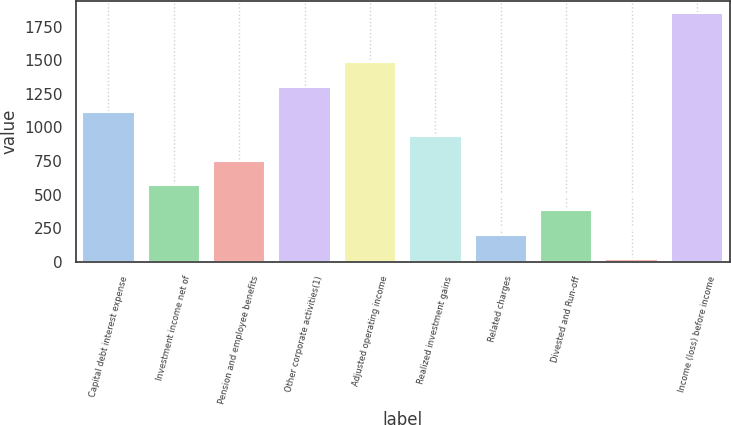Convert chart to OTSL. <chart><loc_0><loc_0><loc_500><loc_500><bar_chart><fcel>Capital debt interest expense<fcel>Investment income net of<fcel>Pension and employee benefits<fcel>Other corporate activities(1)<fcel>Adjusted operating income<fcel>Realized investment gains<fcel>Related charges<fcel>Divested and Run-off<fcel>Unnamed: 8<fcel>Income (loss) before income<nl><fcel>1118.2<fcel>568.6<fcel>751.8<fcel>1301.4<fcel>1484.6<fcel>935<fcel>202.2<fcel>385.4<fcel>19<fcel>1851<nl></chart> 